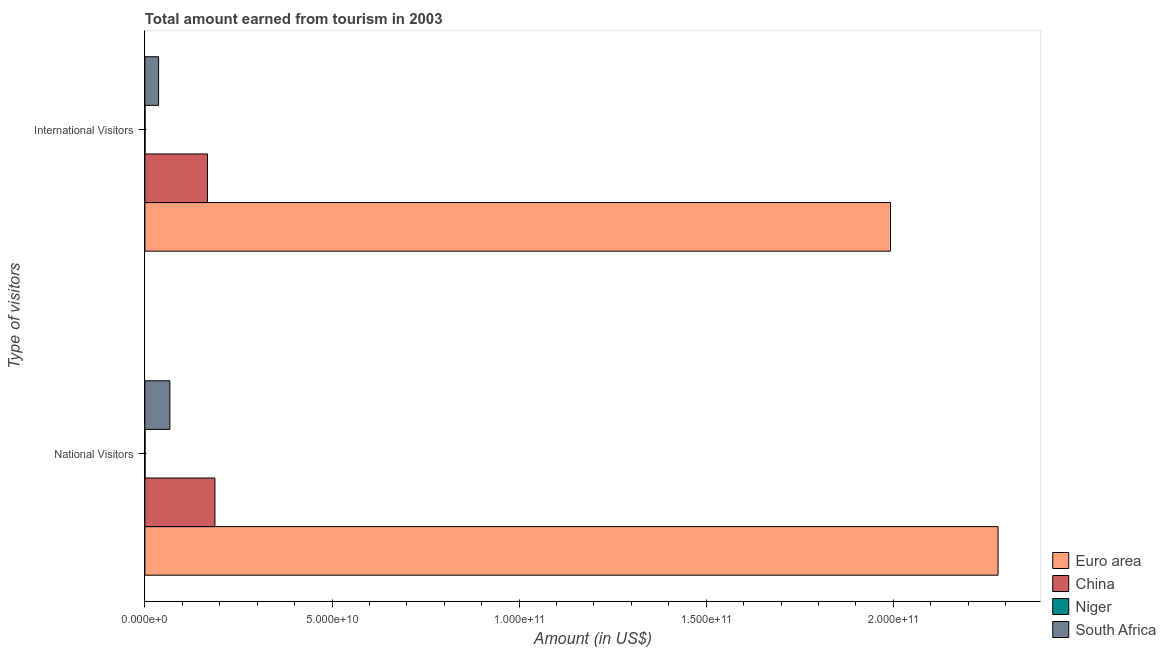How many bars are there on the 1st tick from the top?
Provide a succinct answer. 4. What is the label of the 1st group of bars from the top?
Ensure brevity in your answer.  International Visitors. What is the amount earned from international visitors in China?
Give a very brief answer. 1.67e+1. Across all countries, what is the maximum amount earned from international visitors?
Provide a short and direct response. 1.99e+11. Across all countries, what is the minimum amount earned from international visitors?
Offer a terse response. 3.90e+07. In which country was the amount earned from national visitors maximum?
Provide a short and direct response. Euro area. In which country was the amount earned from international visitors minimum?
Ensure brevity in your answer.  Niger. What is the total amount earned from national visitors in the graph?
Ensure brevity in your answer.  2.53e+11. What is the difference between the amount earned from international visitors in China and that in Niger?
Your answer should be compact. 1.67e+1. What is the difference between the amount earned from international visitors in Niger and the amount earned from national visitors in China?
Keep it short and to the point. -1.87e+1. What is the average amount earned from national visitors per country?
Your answer should be very brief. 6.33e+1. What is the difference between the amount earned from international visitors and amount earned from national visitors in Niger?
Provide a succinct answer. 1.15e+07. In how many countries, is the amount earned from national visitors greater than 40000000000 US$?
Make the answer very short. 1. What is the ratio of the amount earned from international visitors in South Africa to that in Niger?
Provide a succinct answer. 93.72. In how many countries, is the amount earned from national visitors greater than the average amount earned from national visitors taken over all countries?
Your answer should be compact. 1. What does the 4th bar from the top in International Visitors represents?
Your answer should be compact. Euro area. What does the 1st bar from the bottom in National Visitors represents?
Provide a succinct answer. Euro area. Are all the bars in the graph horizontal?
Give a very brief answer. Yes. Does the graph contain any zero values?
Give a very brief answer. No. Where does the legend appear in the graph?
Offer a very short reply. Bottom right. What is the title of the graph?
Provide a short and direct response. Total amount earned from tourism in 2003. What is the label or title of the X-axis?
Offer a terse response. Amount (in US$). What is the label or title of the Y-axis?
Provide a succinct answer. Type of visitors. What is the Amount (in US$) in Euro area in National Visitors?
Offer a terse response. 2.28e+11. What is the Amount (in US$) in China in National Visitors?
Make the answer very short. 1.87e+1. What is the Amount (in US$) of Niger in National Visitors?
Provide a short and direct response. 2.75e+07. What is the Amount (in US$) in South Africa in National Visitors?
Give a very brief answer. 6.67e+09. What is the Amount (in US$) of Euro area in International Visitors?
Ensure brevity in your answer.  1.99e+11. What is the Amount (in US$) of China in International Visitors?
Keep it short and to the point. 1.67e+1. What is the Amount (in US$) in Niger in International Visitors?
Provide a short and direct response. 3.90e+07. What is the Amount (in US$) of South Africa in International Visitors?
Make the answer very short. 3.66e+09. Across all Type of visitors, what is the maximum Amount (in US$) in Euro area?
Your response must be concise. 2.28e+11. Across all Type of visitors, what is the maximum Amount (in US$) of China?
Offer a terse response. 1.87e+1. Across all Type of visitors, what is the maximum Amount (in US$) in Niger?
Your answer should be very brief. 3.90e+07. Across all Type of visitors, what is the maximum Amount (in US$) in South Africa?
Keep it short and to the point. 6.67e+09. Across all Type of visitors, what is the minimum Amount (in US$) in Euro area?
Offer a terse response. 1.99e+11. Across all Type of visitors, what is the minimum Amount (in US$) in China?
Provide a short and direct response. 1.67e+1. Across all Type of visitors, what is the minimum Amount (in US$) in Niger?
Offer a very short reply. 2.75e+07. Across all Type of visitors, what is the minimum Amount (in US$) in South Africa?
Provide a succinct answer. 3.66e+09. What is the total Amount (in US$) in Euro area in the graph?
Provide a short and direct response. 4.27e+11. What is the total Amount (in US$) in China in the graph?
Provide a short and direct response. 3.54e+1. What is the total Amount (in US$) in Niger in the graph?
Keep it short and to the point. 6.65e+07. What is the total Amount (in US$) of South Africa in the graph?
Offer a very short reply. 1.03e+1. What is the difference between the Amount (in US$) of Euro area in National Visitors and that in International Visitors?
Provide a succinct answer. 2.88e+1. What is the difference between the Amount (in US$) of China in National Visitors and that in International Visitors?
Provide a short and direct response. 1.99e+09. What is the difference between the Amount (in US$) of Niger in National Visitors and that in International Visitors?
Give a very brief answer. -1.15e+07. What is the difference between the Amount (in US$) of South Africa in National Visitors and that in International Visitors?
Ensure brevity in your answer.  3.02e+09. What is the difference between the Amount (in US$) of Euro area in National Visitors and the Amount (in US$) of China in International Visitors?
Keep it short and to the point. 2.11e+11. What is the difference between the Amount (in US$) of Euro area in National Visitors and the Amount (in US$) of Niger in International Visitors?
Ensure brevity in your answer.  2.28e+11. What is the difference between the Amount (in US$) in Euro area in National Visitors and the Amount (in US$) in South Africa in International Visitors?
Provide a succinct answer. 2.24e+11. What is the difference between the Amount (in US$) in China in National Visitors and the Amount (in US$) in Niger in International Visitors?
Provide a succinct answer. 1.87e+1. What is the difference between the Amount (in US$) of China in National Visitors and the Amount (in US$) of South Africa in International Visitors?
Offer a very short reply. 1.51e+1. What is the difference between the Amount (in US$) in Niger in National Visitors and the Amount (in US$) in South Africa in International Visitors?
Offer a terse response. -3.63e+09. What is the average Amount (in US$) of Euro area per Type of visitors?
Keep it short and to the point. 2.14e+11. What is the average Amount (in US$) in China per Type of visitors?
Give a very brief answer. 1.77e+1. What is the average Amount (in US$) of Niger per Type of visitors?
Provide a short and direct response. 3.32e+07. What is the average Amount (in US$) in South Africa per Type of visitors?
Offer a terse response. 5.16e+09. What is the difference between the Amount (in US$) in Euro area and Amount (in US$) in China in National Visitors?
Give a very brief answer. 2.09e+11. What is the difference between the Amount (in US$) of Euro area and Amount (in US$) of Niger in National Visitors?
Your answer should be very brief. 2.28e+11. What is the difference between the Amount (in US$) of Euro area and Amount (in US$) of South Africa in National Visitors?
Provide a short and direct response. 2.21e+11. What is the difference between the Amount (in US$) of China and Amount (in US$) of Niger in National Visitors?
Provide a succinct answer. 1.87e+1. What is the difference between the Amount (in US$) in China and Amount (in US$) in South Africa in National Visitors?
Make the answer very short. 1.20e+1. What is the difference between the Amount (in US$) in Niger and Amount (in US$) in South Africa in National Visitors?
Your answer should be very brief. -6.65e+09. What is the difference between the Amount (in US$) in Euro area and Amount (in US$) in China in International Visitors?
Provide a short and direct response. 1.83e+11. What is the difference between the Amount (in US$) in Euro area and Amount (in US$) in Niger in International Visitors?
Offer a very short reply. 1.99e+11. What is the difference between the Amount (in US$) in Euro area and Amount (in US$) in South Africa in International Visitors?
Ensure brevity in your answer.  1.96e+11. What is the difference between the Amount (in US$) in China and Amount (in US$) in Niger in International Visitors?
Ensure brevity in your answer.  1.67e+1. What is the difference between the Amount (in US$) of China and Amount (in US$) of South Africa in International Visitors?
Your response must be concise. 1.31e+1. What is the difference between the Amount (in US$) of Niger and Amount (in US$) of South Africa in International Visitors?
Offer a terse response. -3.62e+09. What is the ratio of the Amount (in US$) in Euro area in National Visitors to that in International Visitors?
Offer a terse response. 1.14. What is the ratio of the Amount (in US$) of China in National Visitors to that in International Visitors?
Ensure brevity in your answer.  1.12. What is the ratio of the Amount (in US$) of Niger in National Visitors to that in International Visitors?
Make the answer very short. 0.71. What is the ratio of the Amount (in US$) of South Africa in National Visitors to that in International Visitors?
Offer a very short reply. 1.83. What is the difference between the highest and the second highest Amount (in US$) of Euro area?
Ensure brevity in your answer.  2.88e+1. What is the difference between the highest and the second highest Amount (in US$) in China?
Keep it short and to the point. 1.99e+09. What is the difference between the highest and the second highest Amount (in US$) in Niger?
Make the answer very short. 1.15e+07. What is the difference between the highest and the second highest Amount (in US$) in South Africa?
Provide a succinct answer. 3.02e+09. What is the difference between the highest and the lowest Amount (in US$) in Euro area?
Offer a very short reply. 2.88e+1. What is the difference between the highest and the lowest Amount (in US$) of China?
Give a very brief answer. 1.99e+09. What is the difference between the highest and the lowest Amount (in US$) in Niger?
Make the answer very short. 1.15e+07. What is the difference between the highest and the lowest Amount (in US$) of South Africa?
Your answer should be very brief. 3.02e+09. 